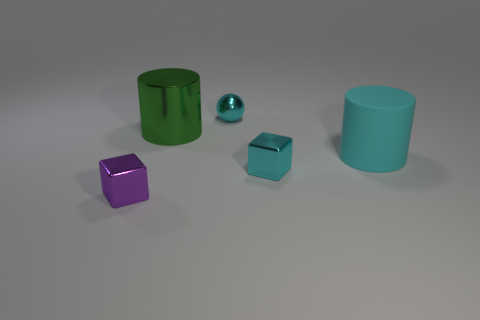Subtract all brown cylinders. Subtract all blue blocks. How many cylinders are left? 2 Add 2 metallic objects. How many objects exist? 7 Subtract all spheres. How many objects are left? 4 Add 5 cyan shiny things. How many cyan shiny things are left? 7 Add 1 cyan spheres. How many cyan spheres exist? 2 Subtract 1 green cylinders. How many objects are left? 4 Subtract all cyan objects. Subtract all green cylinders. How many objects are left? 1 